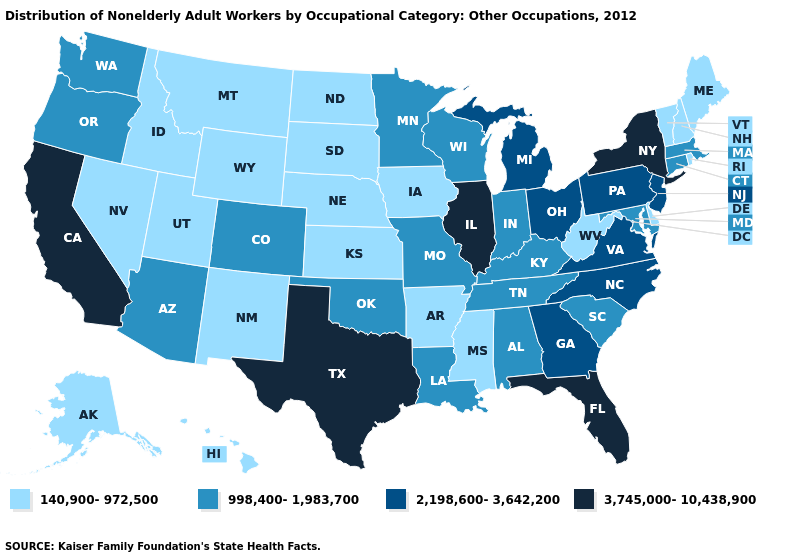What is the value of Louisiana?
Answer briefly. 998,400-1,983,700. Which states have the lowest value in the Northeast?
Quick response, please. Maine, New Hampshire, Rhode Island, Vermont. Name the states that have a value in the range 140,900-972,500?
Keep it brief. Alaska, Arkansas, Delaware, Hawaii, Idaho, Iowa, Kansas, Maine, Mississippi, Montana, Nebraska, Nevada, New Hampshire, New Mexico, North Dakota, Rhode Island, South Dakota, Utah, Vermont, West Virginia, Wyoming. What is the value of Wisconsin?
Keep it brief. 998,400-1,983,700. Which states have the lowest value in the USA?
Concise answer only. Alaska, Arkansas, Delaware, Hawaii, Idaho, Iowa, Kansas, Maine, Mississippi, Montana, Nebraska, Nevada, New Hampshire, New Mexico, North Dakota, Rhode Island, South Dakota, Utah, Vermont, West Virginia, Wyoming. Among the states that border Texas , does New Mexico have the highest value?
Answer briefly. No. What is the value of Missouri?
Write a very short answer. 998,400-1,983,700. What is the highest value in the USA?
Answer briefly. 3,745,000-10,438,900. How many symbols are there in the legend?
Answer briefly. 4. Does Colorado have the same value as Louisiana?
Be succinct. Yes. Does North Carolina have the lowest value in the USA?
Give a very brief answer. No. Does the map have missing data?
Short answer required. No. Is the legend a continuous bar?
Concise answer only. No. Does Alaska have a higher value than Tennessee?
Be succinct. No. What is the value of New York?
Answer briefly. 3,745,000-10,438,900. 